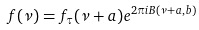Convert formula to latex. <formula><loc_0><loc_0><loc_500><loc_500>f ( \nu ) = f _ { \tau } ( \nu + a ) e ^ { 2 \pi i B ( \nu + a , b ) }</formula> 